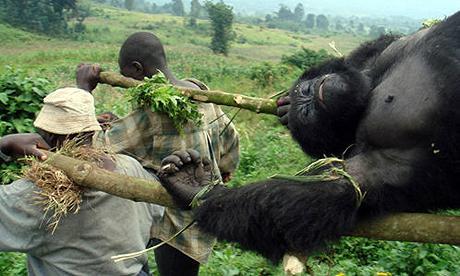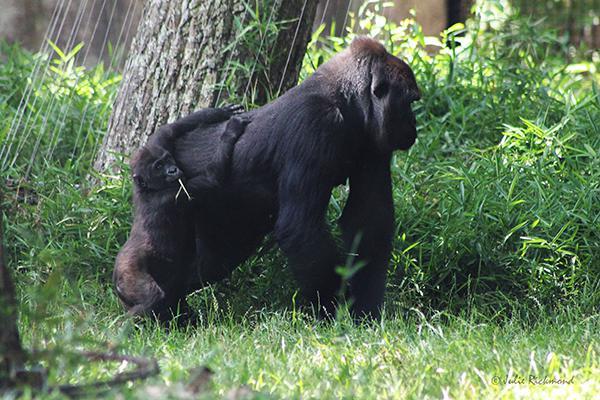The first image is the image on the left, the second image is the image on the right. Evaluate the accuracy of this statement regarding the images: "The right image includes an adult gorilla on all fours in the foreground, and the left image includes a large gorilla, multiple people, and someone upside down and off their feet.". Is it true? Answer yes or no. Yes. 